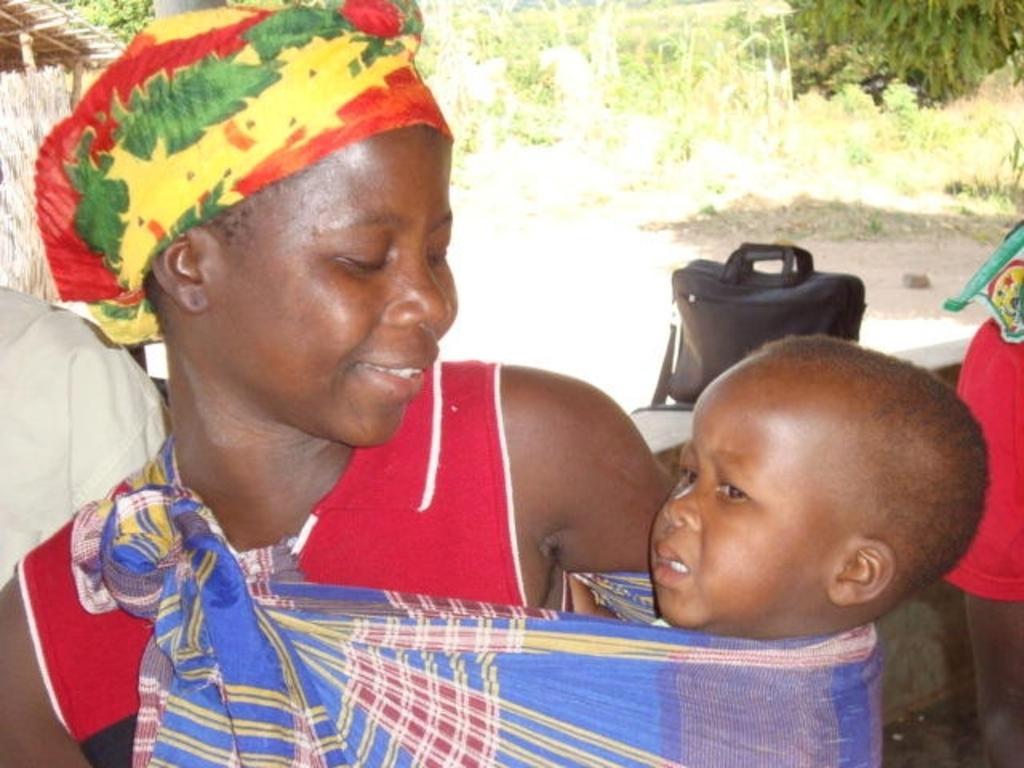Could you give a brief overview of what you see in this image? In this image on the left side we can see a woman and she is carrying a kid in a cloth which is tied to her shoulder. In the background we can see a bag on a platform, plants, two persons shoulders and other objects. 